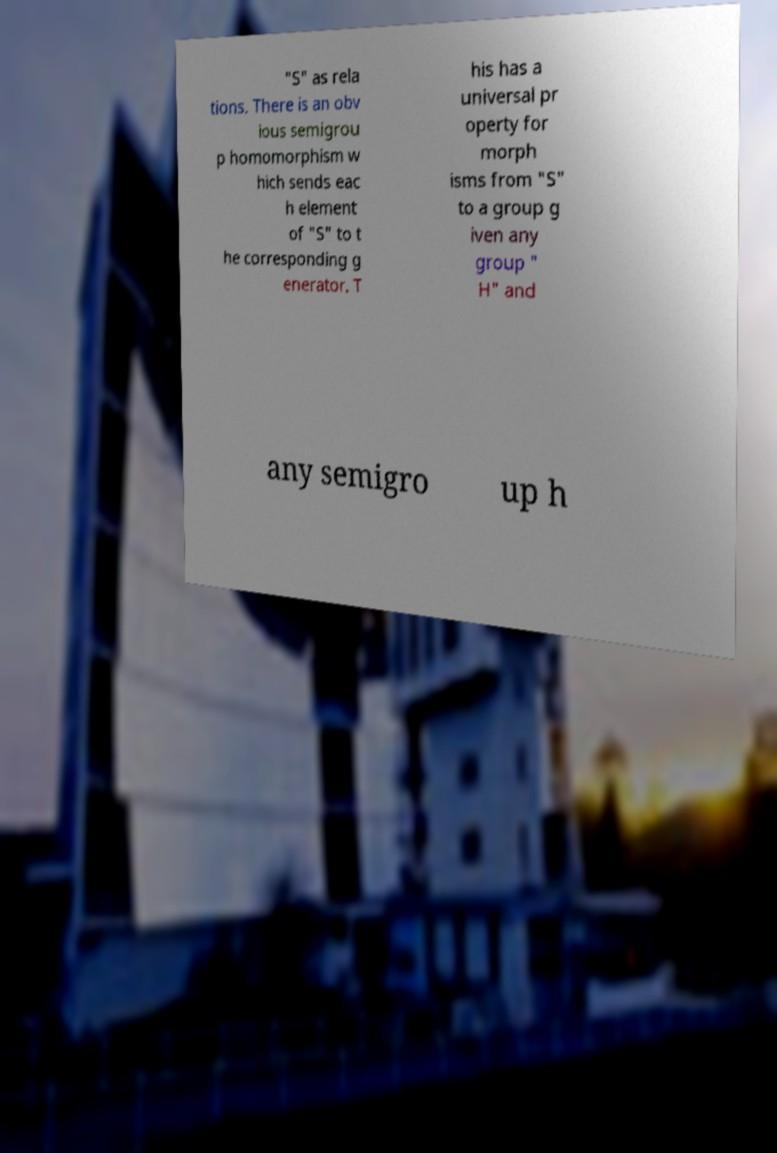Can you accurately transcribe the text from the provided image for me? "S" as rela tions. There is an obv ious semigrou p homomorphism w hich sends eac h element of "S" to t he corresponding g enerator. T his has a universal pr operty for morph isms from "S" to a group g iven any group " H" and any semigro up h 